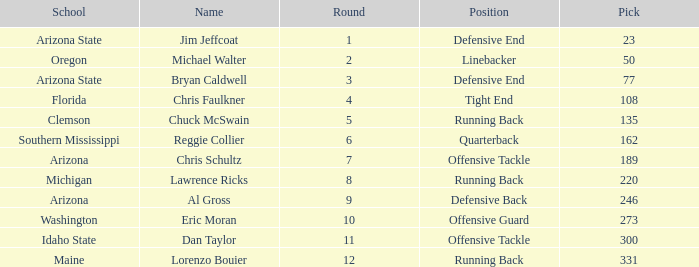What is the number of the pick for round 11? 300.0. 